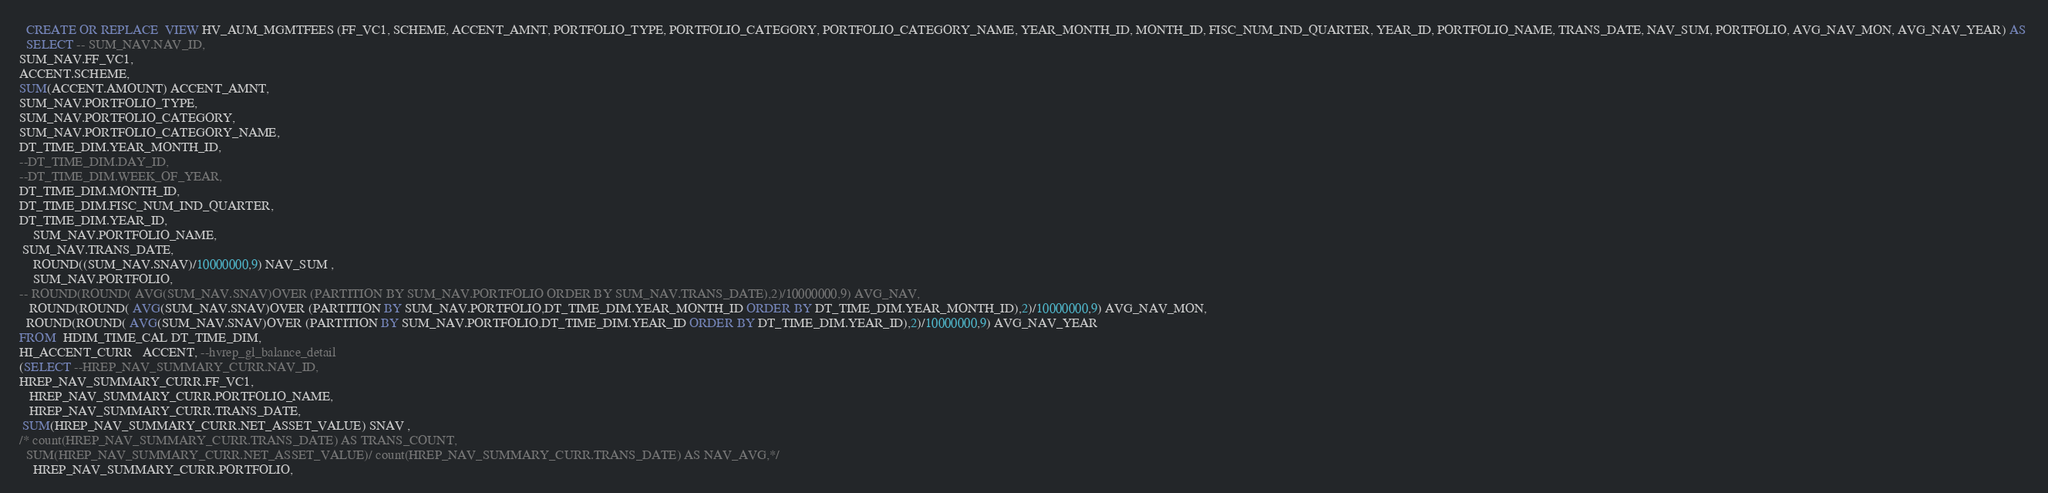<code> <loc_0><loc_0><loc_500><loc_500><_SQL_>
  CREATE OR REPLACE  VIEW HV_AUM_MGMTFEES (FF_VC1, SCHEME, ACCENT_AMNT, PORTFOLIO_TYPE, PORTFOLIO_CATEGORY, PORTFOLIO_CATEGORY_NAME, YEAR_MONTH_ID, MONTH_ID, FISC_NUM_IND_QUARTER, YEAR_ID, PORTFOLIO_NAME, TRANS_DATE, NAV_SUM, PORTFOLIO, AVG_NAV_MON, AVG_NAV_YEAR) AS 
  SELECT -- SUM_NAV.NAV_ID,
SUM_NAV.FF_VC1,
ACCENT.SCHEME, 
SUM(ACCENT.AMOUNT) ACCENT_AMNT,
SUM_NAV.PORTFOLIO_TYPE,
SUM_NAV.PORTFOLIO_CATEGORY,
SUM_NAV.PORTFOLIO_CATEGORY_NAME,
DT_TIME_DIM.YEAR_MONTH_ID,
--DT_TIME_DIM.DAY_ID,
--DT_TIME_DIM.WEEK_OF_YEAR,
DT_TIME_DIM.MONTH_ID,
DT_TIME_DIM.FISC_NUM_IND_QUARTER,
DT_TIME_DIM.YEAR_ID,
    SUM_NAV.PORTFOLIO_NAME,
 SUM_NAV.TRANS_DATE,
    ROUND((SUM_NAV.SNAV)/10000000,9) NAV_SUM ,
    SUM_NAV.PORTFOLIO,
-- ROUND(ROUND( AVG(SUM_NAV.SNAV)OVER (PARTITION BY SUM_NAV.PORTFOLIO ORDER BY SUM_NAV.TRANS_DATE),2)/10000000,9) AVG_NAV,
   ROUND(ROUND( AVG(SUM_NAV.SNAV)OVER (PARTITION BY SUM_NAV.PORTFOLIO,DT_TIME_DIM.YEAR_MONTH_ID ORDER BY DT_TIME_DIM.YEAR_MONTH_ID),2)/10000000,9) AVG_NAV_MON,
  ROUND(ROUND( AVG(SUM_NAV.SNAV)OVER (PARTITION BY SUM_NAV.PORTFOLIO,DT_TIME_DIM.YEAR_ID ORDER BY DT_TIME_DIM.YEAR_ID),2)/10000000,9) AVG_NAV_YEAR
FROM  HDIM_TIME_CAL DT_TIME_DIM,
HI_ACCENT_CURR   ACCENT, --hvrep_gl_balance_detail
(SELECT --HREP_NAV_SUMMARY_CURR.NAV_ID,
HREP_NAV_SUMMARY_CURR.FF_VC1,
   HREP_NAV_SUMMARY_CURR.PORTFOLIO_NAME,
   HREP_NAV_SUMMARY_CURR.TRANS_DATE,
 SUM(HREP_NAV_SUMMARY_CURR.NET_ASSET_VALUE) SNAV ,
/* count(HREP_NAV_SUMMARY_CURR.TRANS_DATE) AS TRANS_COUNT,
  SUM(HREP_NAV_SUMMARY_CURR.NET_ASSET_VALUE)/ count(HREP_NAV_SUMMARY_CURR.TRANS_DATE) AS NAV_AVG,*/
    HREP_NAV_SUMMARY_CURR.PORTFOLIO,</code> 